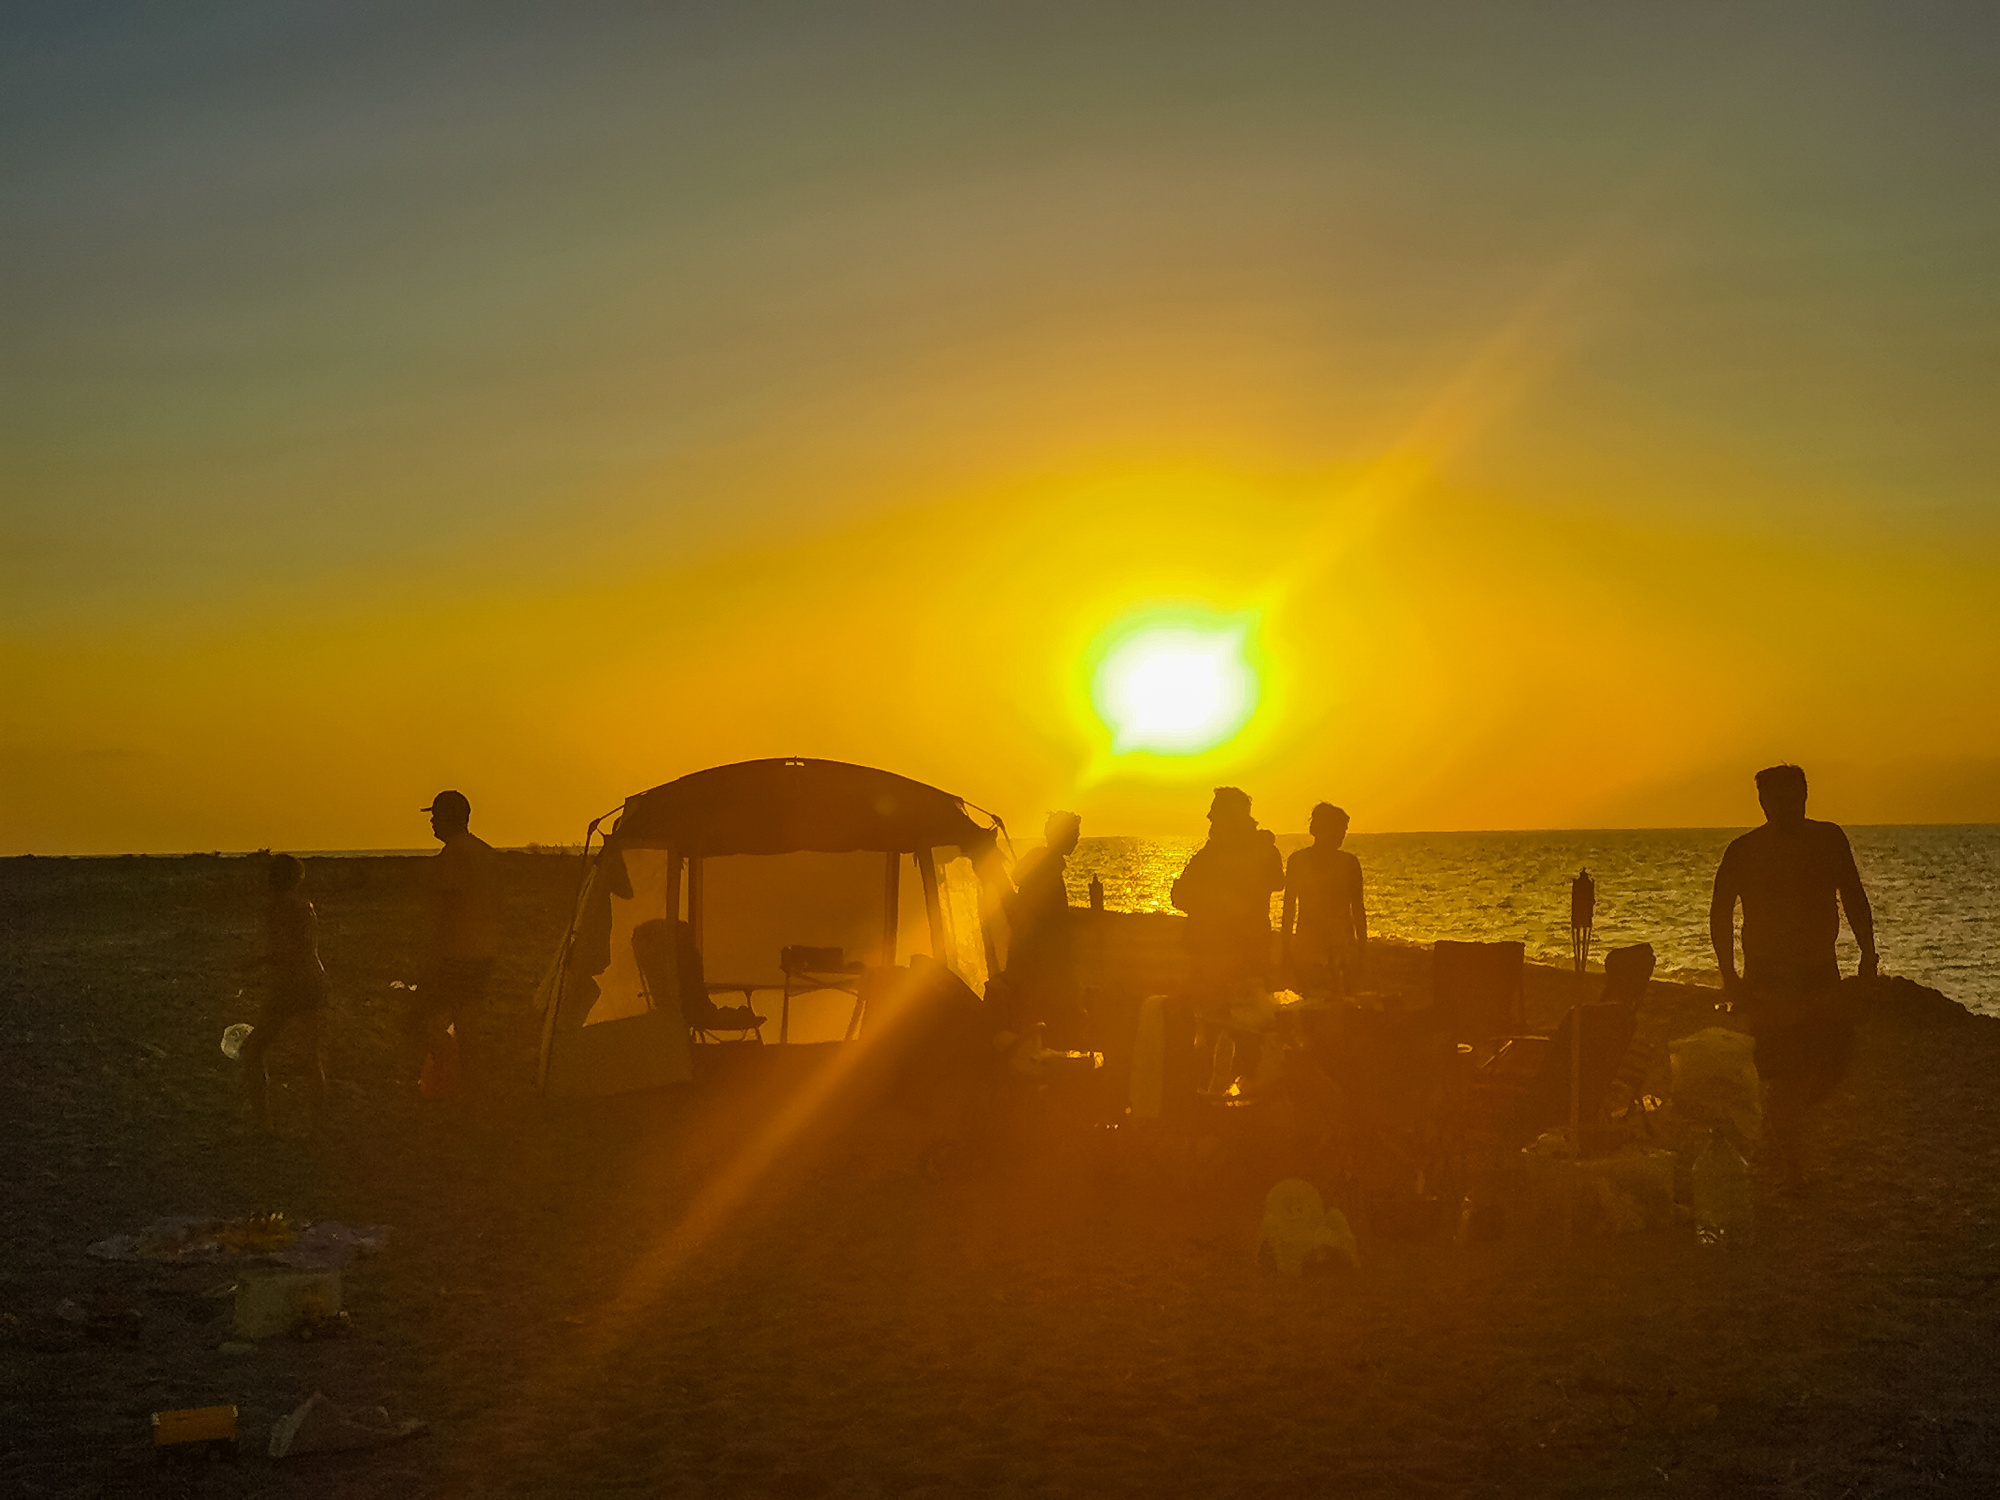Can you describe the mood on this beach as the sun sets? As the sun sets, the mood on the beach is one of bittersweet tranquility. There's a contemplative silence hanging in the air, punctuated by the lull of waves and the distant laughter of those reluctant to end the day. It's a time of reflection, of soaking in the last warm rays of the day, and of the calming presence of friends and family surrounding you. 